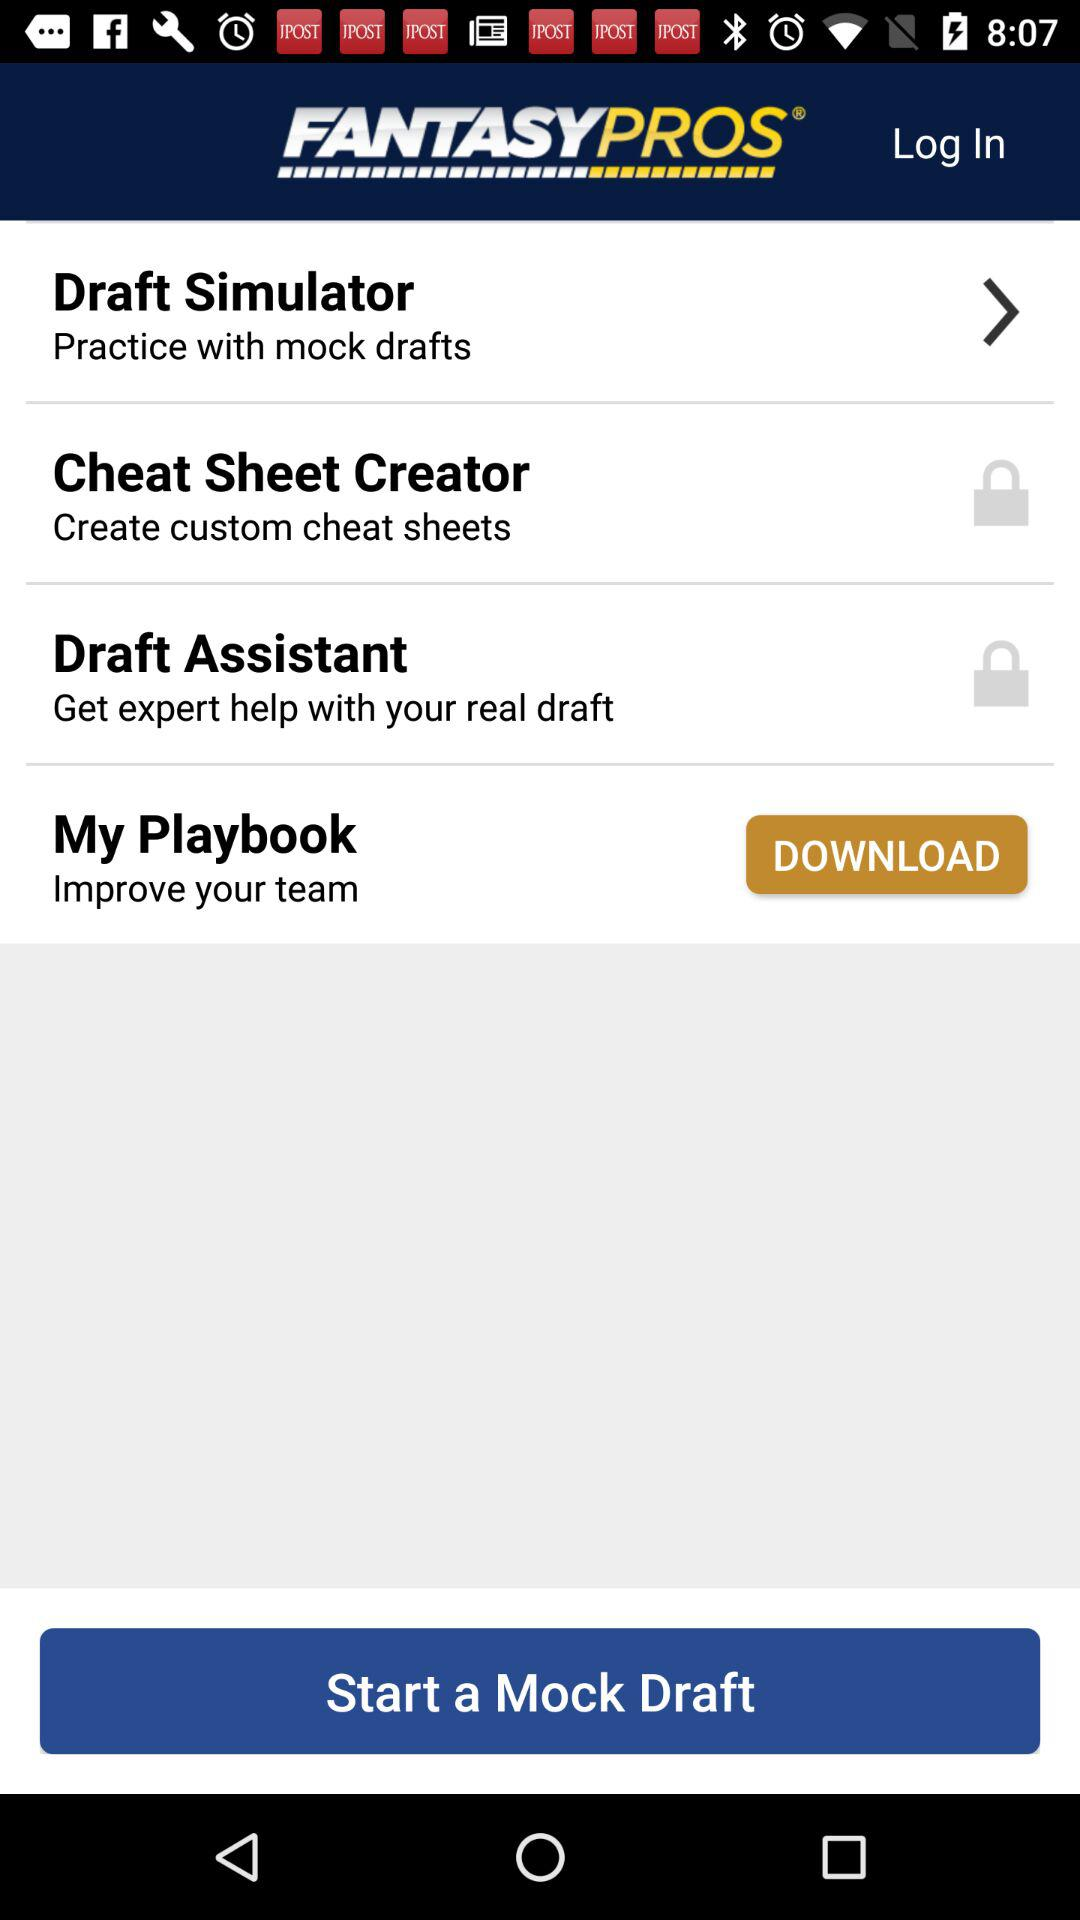What is the name of the application? The name of the application is "FANTASYPROS". 